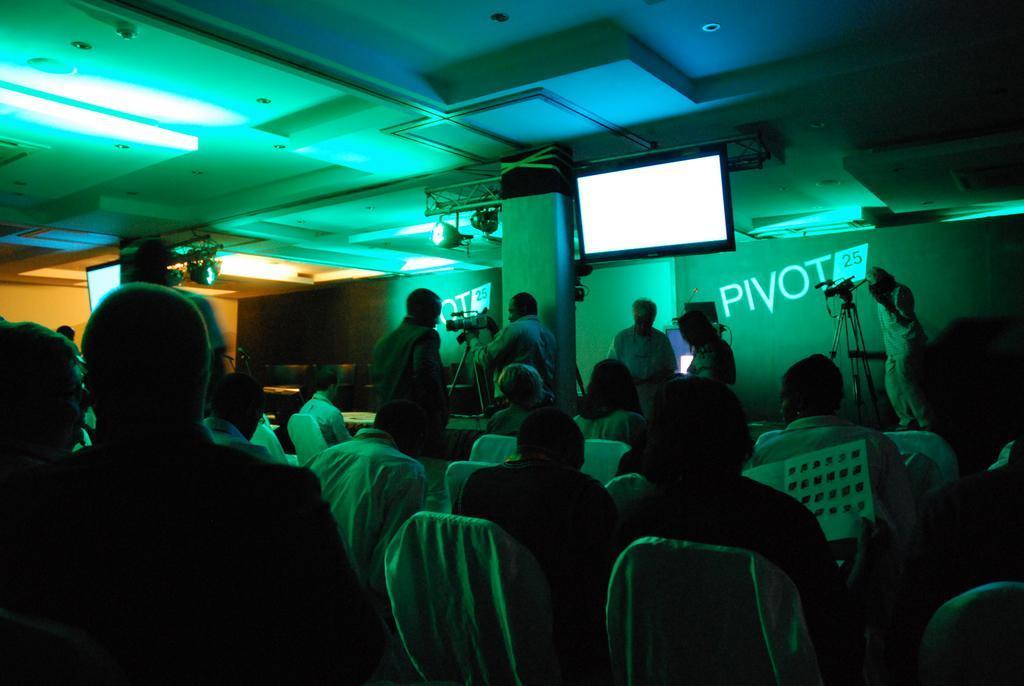Please provide a concise description of this image. In the picture we can see a dark room in it, we can see a some people are sitting in the chairs and in front of them, we can see some people are standing and setting the camera which is on the tripod and behind them, we can see a pillar with a TV to it and behind it we can see a wall with the screen and to the ceiling we can see some lights. 